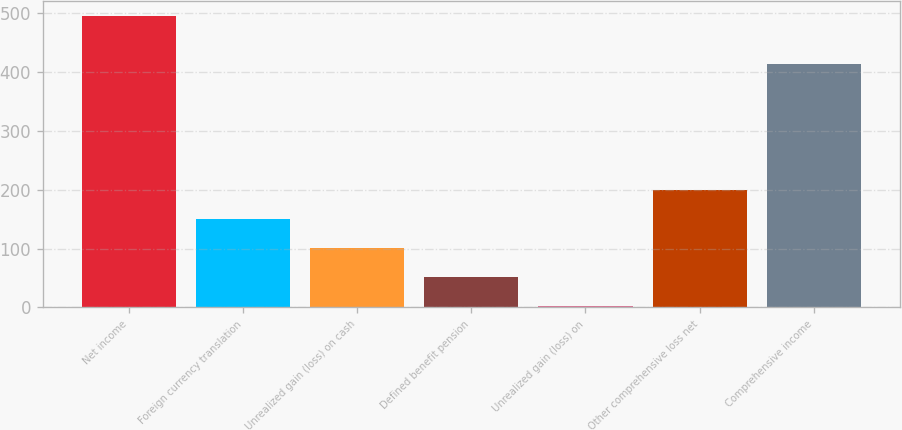<chart> <loc_0><loc_0><loc_500><loc_500><bar_chart><fcel>Net income<fcel>Foreign currency translation<fcel>Unrealized gain (loss) on cash<fcel>Defined benefit pension<fcel>Unrealized gain (loss) on<fcel>Other comprehensive loss net<fcel>Comprehensive income<nl><fcel>494.9<fcel>150.29<fcel>101.06<fcel>51.83<fcel>2.6<fcel>199.52<fcel>413.2<nl></chart> 